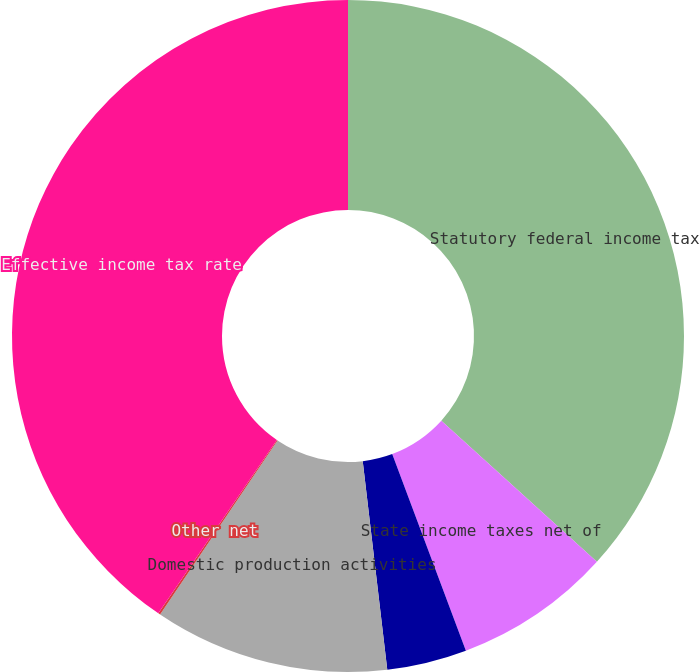Convert chart to OTSL. <chart><loc_0><loc_0><loc_500><loc_500><pie_chart><fcel>Statutory federal income tax<fcel>State income taxes net of<fcel>Unconsolidated affiliate tax<fcel>Domestic production activities<fcel>Other net<fcel>Effective income tax rate<nl><fcel>36.72%<fcel>7.57%<fcel>3.84%<fcel>11.31%<fcel>0.1%<fcel>40.45%<nl></chart> 